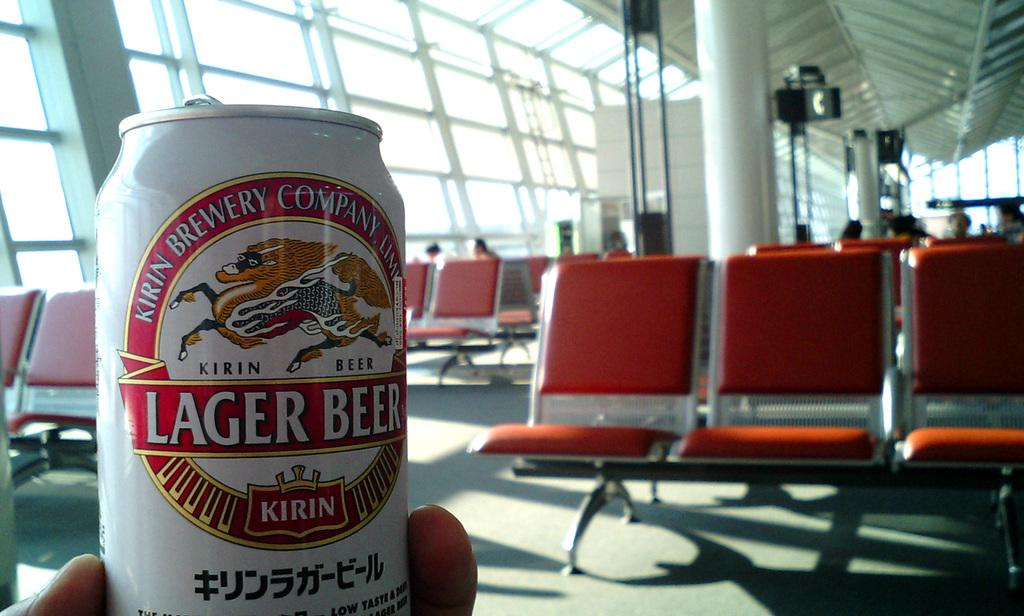<image>
Write a terse but informative summary of the picture. a can of beer  that says Lager on it 